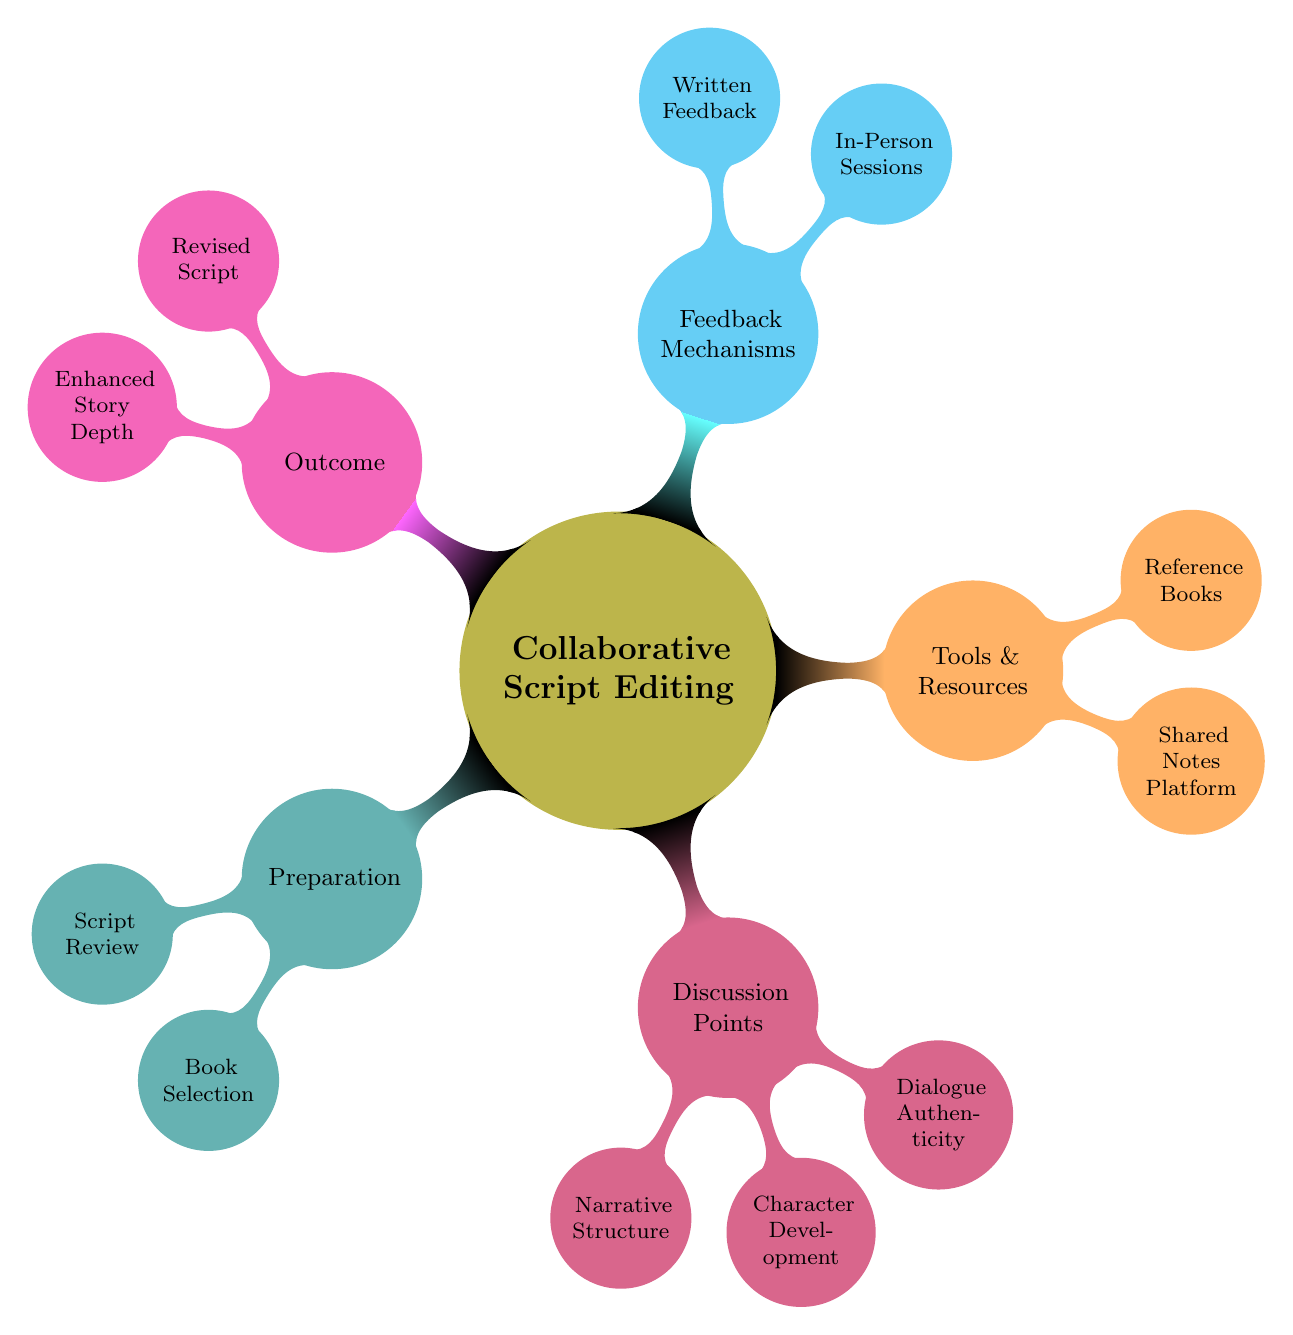What is the first step in Preparation? The first node under the Preparation category is "Script Review," which indicates an initial draft review by the screenwriter.
Answer: Script Review How many main categories are there in the mind map? The diagram has five main categories: Preparation, Discussion Points, Tools & Resources, Feedback Mechanisms, and Outcome.
Answer: 5 What are the two nodes listed under Tools & Resources? The nodes under Tools & Resources are "Shared Notes Platform" and "Reference Books," which suggest the tools and resources used in the collaborative sessions.
Answer: Shared Notes Platform, Reference Books Which category contains "Character Development"? "Character Development" is found under the category "Discussion Points," indicating a focus area during the collaborative editing sessions.
Answer: Discussion Points How does "Feedback Mechanisms" lead to the "Outcome"? "Feedback Mechanisms," which includes In-Person Sessions and Written Feedback, provides the necessary input to achieve the desired "Outcome" of a Revised Script and Enhanced Story Depth.
Answer: Through feedback What is the significance of "Reference Books"? "Reference Books" serves as a resource to leverage thematic and genre-specific knowledge from literature to enhance the script writing process, shown under Tools & Resources.
Answer: Resource for enhancement What is the final goal of the collaborative script editing sessions? The ultimate aims are producing a "Revised Script" and "Enhanced Story Depth," which emphasize improvements in the script and deeper insights.
Answer: Revised Script, Enhanced Story Depth Which discussion point focuses on authenticity? The discussion point that emphasizes authenticity is "Dialogue Authenticity," which ensures that the dialogue in the script is realistic and engaging.
Answer: Dialogue Authenticity What tool is used for real-time collaboration? The tool used for real-time collaboration is "Google Docs," as stated under Tools & Resources in the diagram.
Answer: Google Docs 